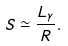Convert formula to latex. <formula><loc_0><loc_0><loc_500><loc_500>S \simeq \frac { L _ { \gamma } } { R } .</formula> 